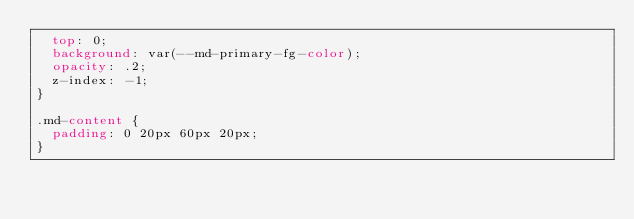<code> <loc_0><loc_0><loc_500><loc_500><_CSS_>  top: 0;
  background: var(--md-primary-fg-color);
  opacity: .2;
  z-index: -1;
}

.md-content {
  padding: 0 20px 60px 20px;
}
</code> 